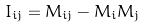Convert formula to latex. <formula><loc_0><loc_0><loc_500><loc_500>I _ { i j } = M _ { i j } - M _ { i } M _ { j }</formula> 